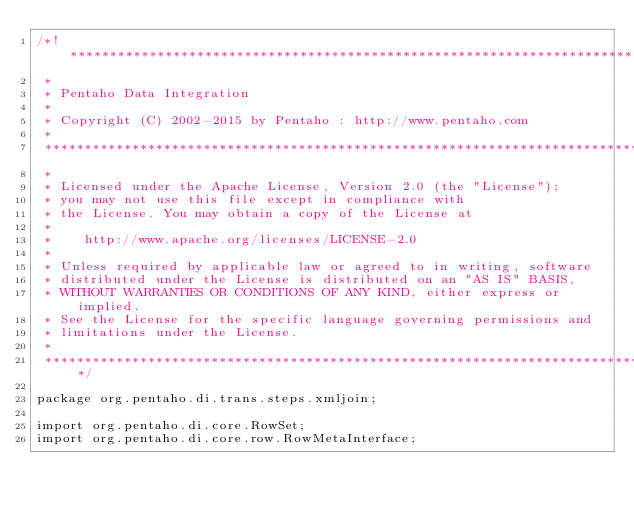<code> <loc_0><loc_0><loc_500><loc_500><_Java_>/*! ******************************************************************************
 *
 * Pentaho Data Integration
 *
 * Copyright (C) 2002-2015 by Pentaho : http://www.pentaho.com
 *
 *******************************************************************************
 *
 * Licensed under the Apache License, Version 2.0 (the "License");
 * you may not use this file except in compliance with
 * the License. You may obtain a copy of the License at
 *
 *    http://www.apache.org/licenses/LICENSE-2.0
 *
 * Unless required by applicable law or agreed to in writing, software
 * distributed under the License is distributed on an "AS IS" BASIS,
 * WITHOUT WARRANTIES OR CONDITIONS OF ANY KIND, either express or implied.
 * See the License for the specific language governing permissions and
 * limitations under the License.
 *
 ******************************************************************************/

package org.pentaho.di.trans.steps.xmljoin;

import org.pentaho.di.core.RowSet;
import org.pentaho.di.core.row.RowMetaInterface;</code> 